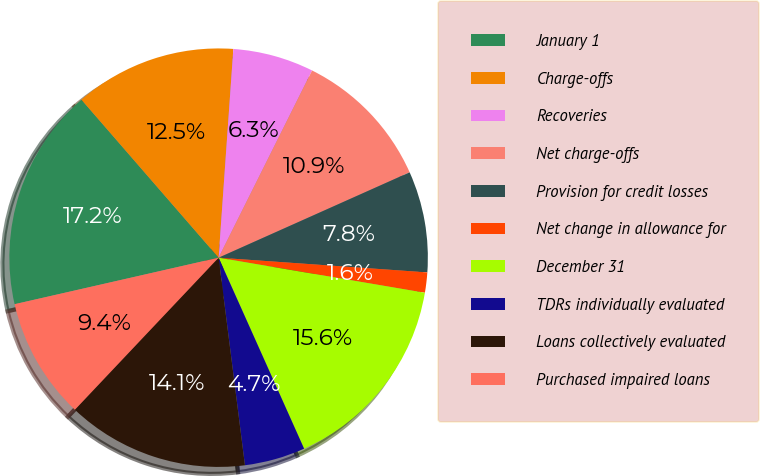Convert chart. <chart><loc_0><loc_0><loc_500><loc_500><pie_chart><fcel>January 1<fcel>Charge-offs<fcel>Recoveries<fcel>Net charge-offs<fcel>Provision for credit losses<fcel>Net change in allowance for<fcel>December 31<fcel>TDRs individually evaluated<fcel>Loans collectively evaluated<fcel>Purchased impaired loans<nl><fcel>17.19%<fcel>12.5%<fcel>6.25%<fcel>10.94%<fcel>7.81%<fcel>1.56%<fcel>15.62%<fcel>4.69%<fcel>14.06%<fcel>9.38%<nl></chart> 